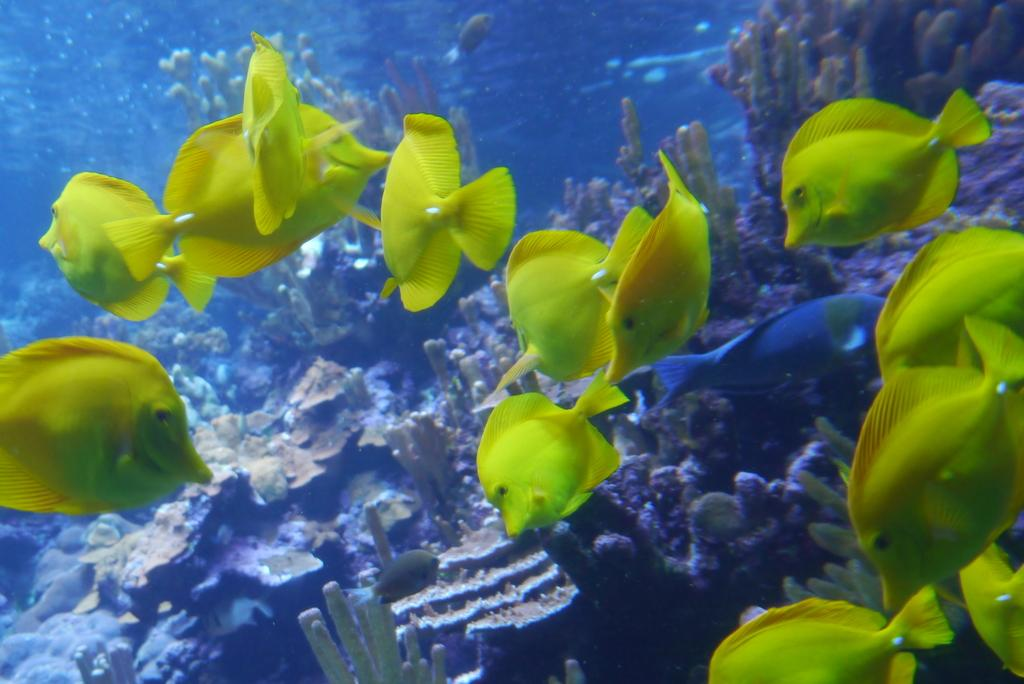What type of animals can be seen in the image? There are fishes in the image. What other living organisms are present in the image? There are marine plants in the image. Where are the fishes and marine plants located? The fishes and marine plants are in water. What type of hook can be seen in the image? There is no hook present in the image. How many brothers are visible in the image? There are no people, including brothers, present in the image. 